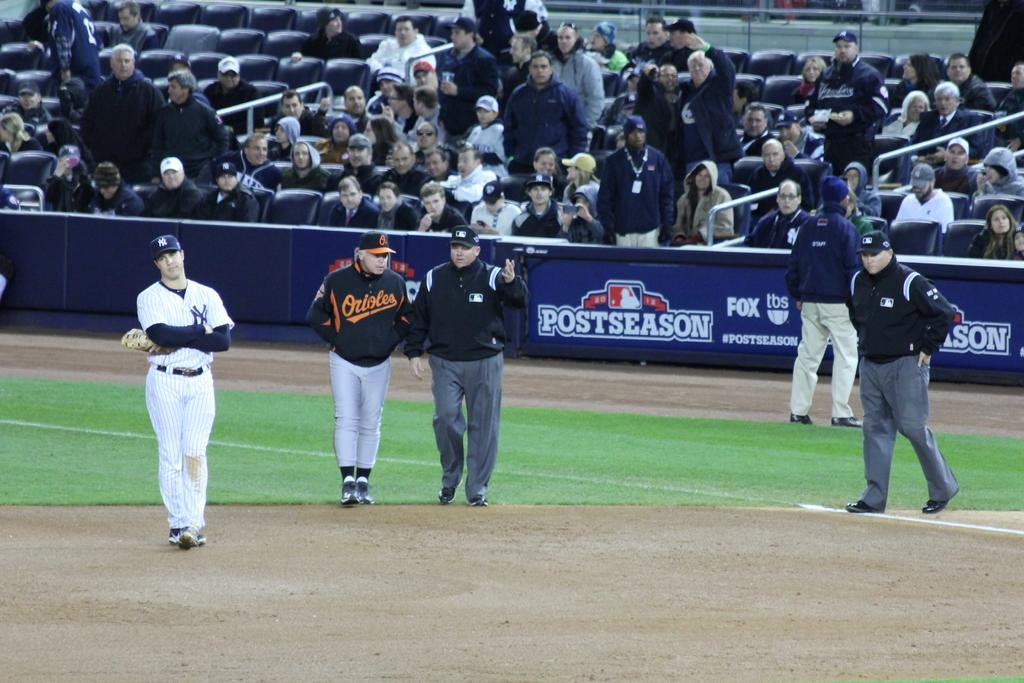<image>
Give a short and clear explanation of the subsequent image. ny yankees and orioles playing a postseason mlb game 